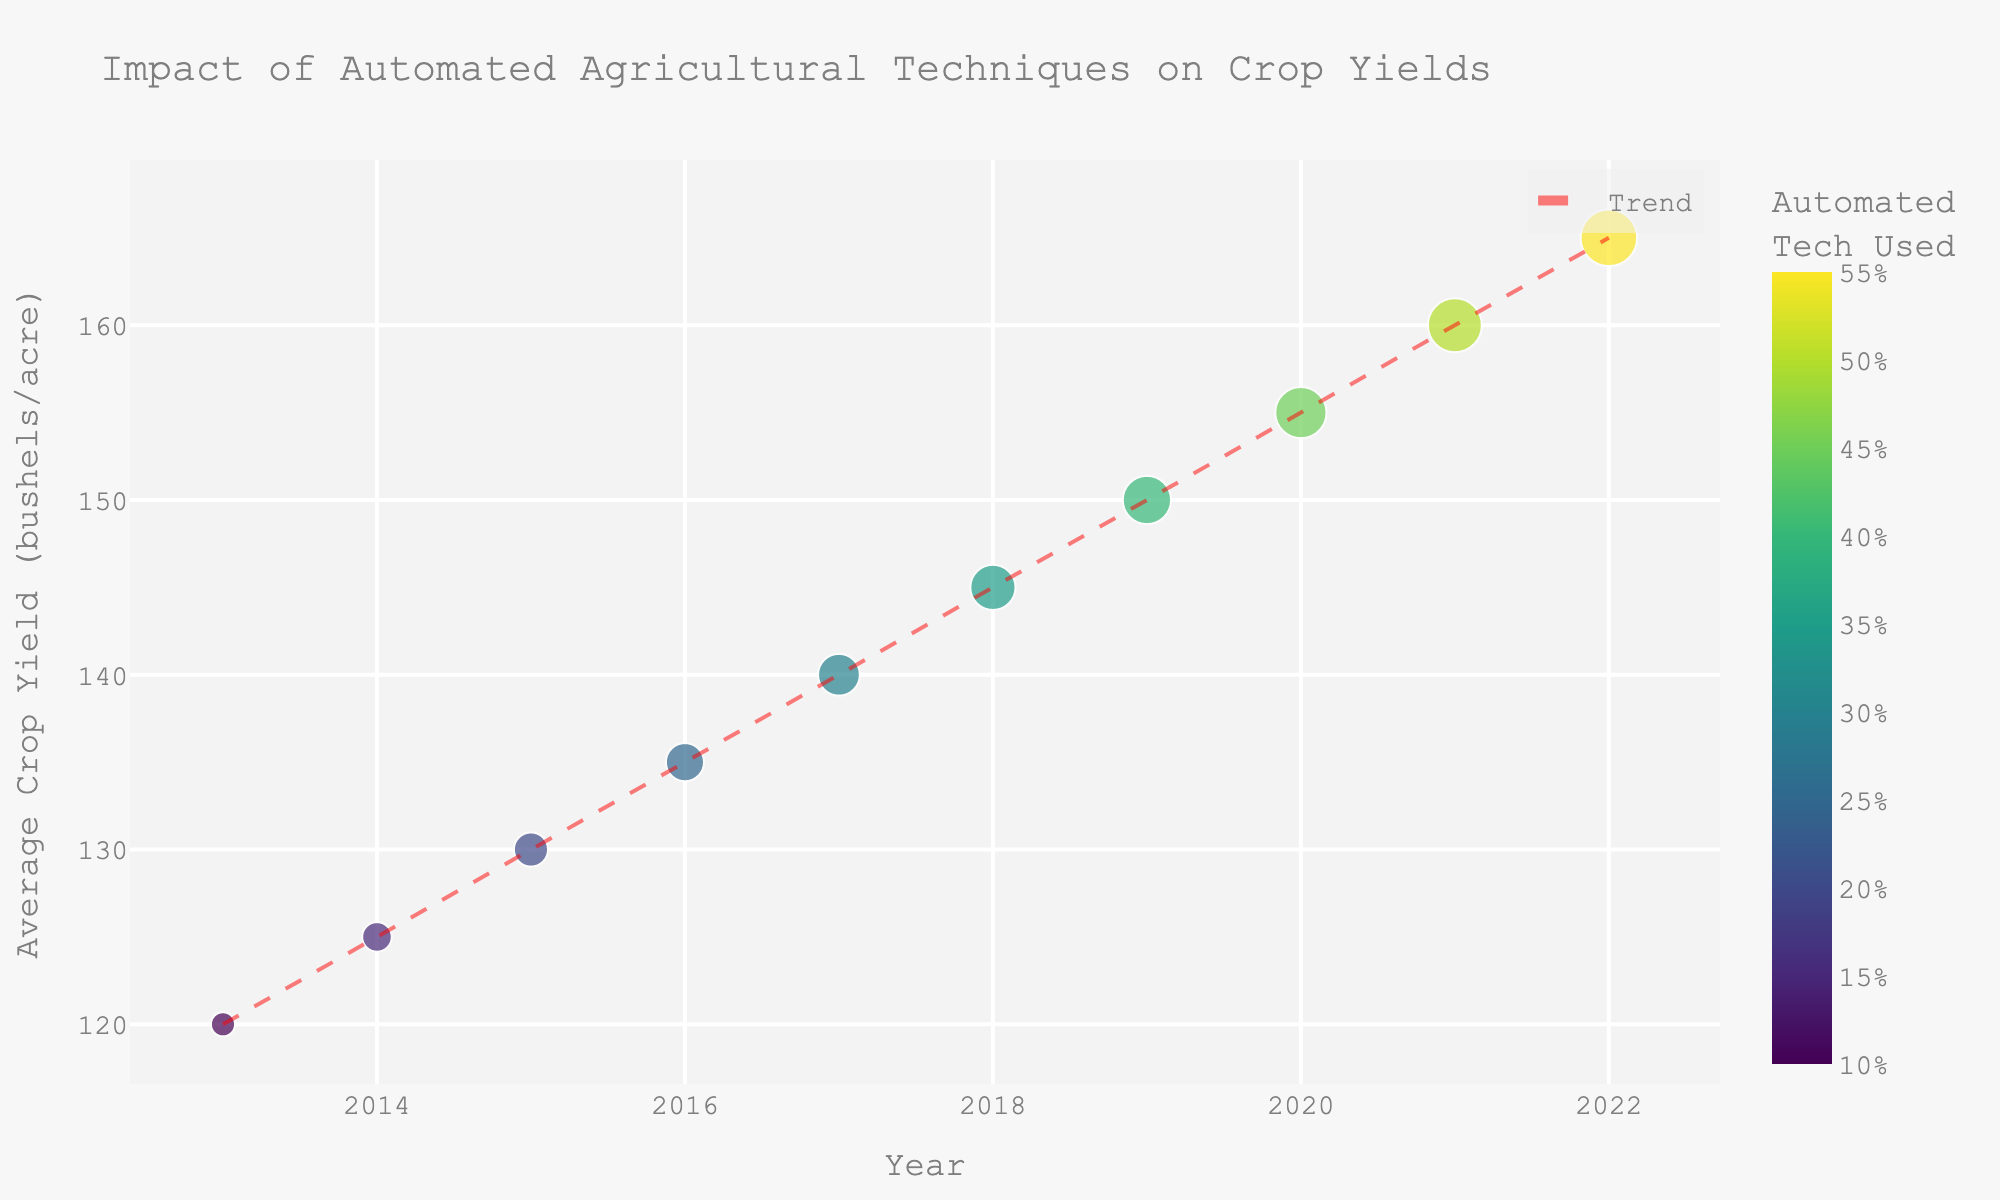What's the title of the figure? The title of the figure is displayed prominently at the top and it states the main focus of the graph.
Answer: Impact of Automated Agricultural Techniques on Crop Yields What are the x-axis and y-axis labels? The x-axis represents the timeline of the data, and the label specifies "Year". The y-axis represents the measurement of interest, labeled as "Average Crop Yield (bushels/acre)".
Answer: Year; Average Crop Yield (bushels/acre) How does the use of automated technology change from 2013 to 2022? Based on the scatter plot, the percentage of automated technology used increases gradually from 2013 to 2022. Observing the plot, the percentage starts at 10% in 2013 and rises to 55% in 2022.
Answer: It increases from 10% to 55% Which year had the highest average crop yield per acre? By examining the scatter plot's vertical axis and finding the highest point, you can determine the year with the highest crop yield. The highest point appears at 165 bushels/acre in 2022.
Answer: 2022 Describe the trend in average crop yield over the years. Looking at the trend line, there is a clear upward slope indicating a consistent increase in average crop yield from 2013 to 2022. The positive slope of the trend line confirms this upward trend.
Answer: It increases steadily How many data points are shown in the figure? Counting each point plotted in the scatter plot along the timeline allows you to determine the total number of data points.
Answer: 10 Is there a positive or negative correlation between the percentage of automated technology used and average crop yield? The trend line and the distribution of points suggest a positive correlation—both variables increase together over time.
Answer: Positive correlation What is the average crop yield per acre in the year when 40% automated technology was used? Identify the point corresponding to the year when 40% automation was used and read the y-axis value. In the year 2019 with 40% automation, the yield is 150 bushels/acre.
Answer: 150 bushels/acre Between which two years is the largest increase in average crop yield observed? Examine the differences in crop yield between consecutive points to find the largest jump. The biggest increase happens between 2021 and 2022, from 160 to 165 bushels/acre, an increase of 5 bushels/acre.
Answer: Between 2021 and 2022 What would be the expected average crop yield in 2023 if the trend continues? Using the trend line's equation, you can extend the line to make a prediction for 2023. The approximate yearly increase is around 5 bushels based on the plot. Adding 5 to the 2022 yield of 165 bushels/acre yields 170 bushels/acre for 2023.
Answer: 170 bushels/acre 